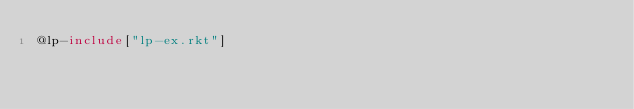Convert code to text. <code><loc_0><loc_0><loc_500><loc_500><_Racket_>@lp-include["lp-ex.rkt"]
</code> 